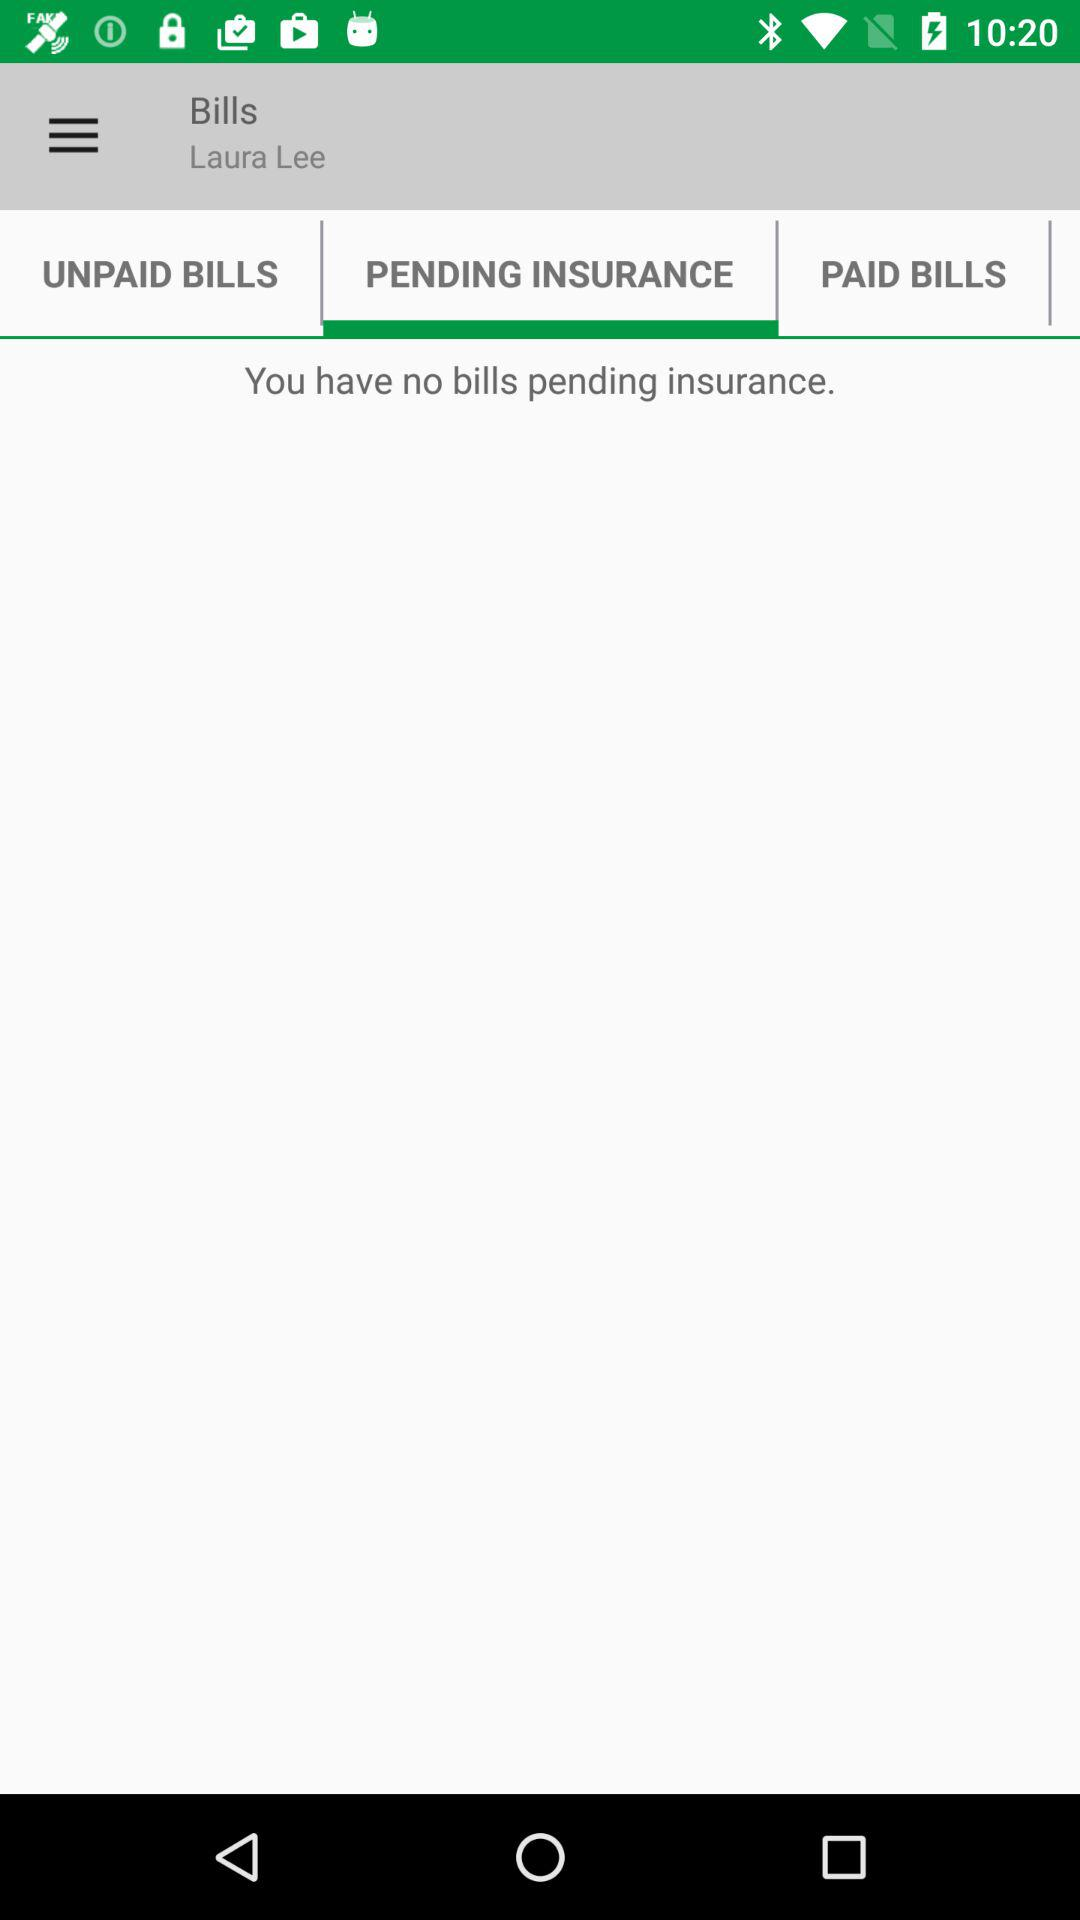Are there any insurance bills pending? There are no pending bills. 